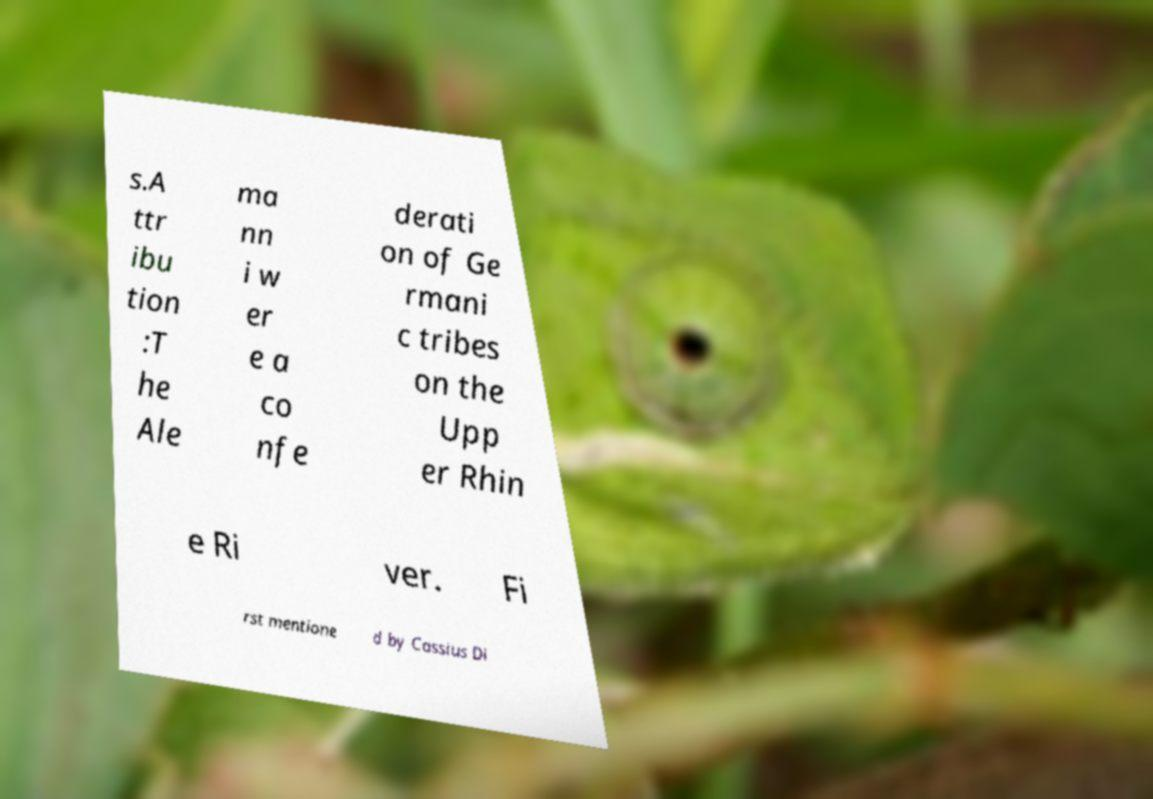Could you assist in decoding the text presented in this image and type it out clearly? s.A ttr ibu tion :T he Ale ma nn i w er e a co nfe derati on of Ge rmani c tribes on the Upp er Rhin e Ri ver. Fi rst mentione d by Cassius Di 